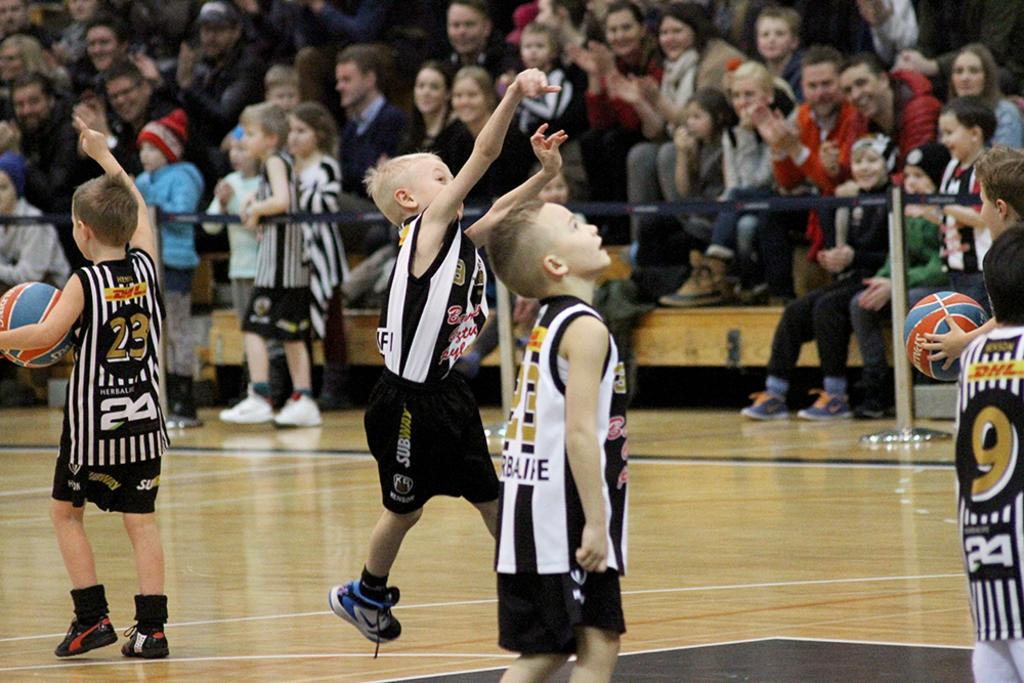What are the small boys doing in the court? The boys are playing basketball in the court. Who is watching the boys play basketball? There is an audience sitting and enjoying the game. What type of branch can be seen in the hands of the boys while they are playing basketball? There are no branches present in the image; the boys are playing basketball with a ball. How many potatoes are visible in the image? There are no potatoes present in the image. 